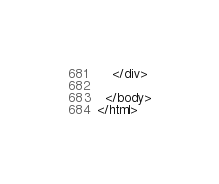<code> <loc_0><loc_0><loc_500><loc_500><_HTML_>    </div>

  </body>
</html>
</code> 